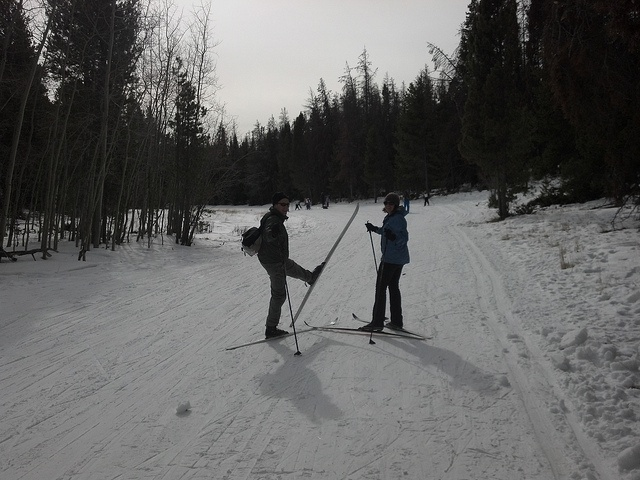Describe the objects in this image and their specific colors. I can see people in black, darkgray, and gray tones, people in black, darkgray, gray, and lightgray tones, skis in black, gray, and lightgray tones, backpack in black, gray, darkgray, and lightgray tones, and skis in black and gray tones in this image. 